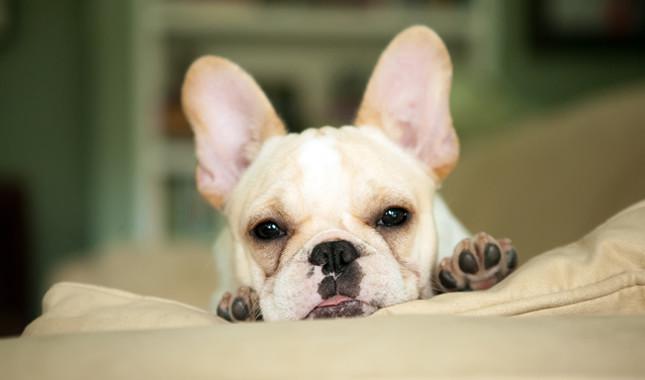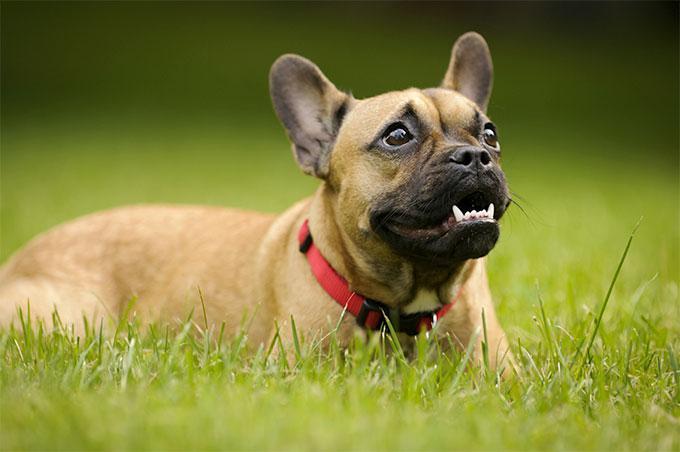The first image is the image on the left, the second image is the image on the right. Given the left and right images, does the statement "the pupply on the left image has its head laying flat on a surface" hold true? Answer yes or no. Yes. 